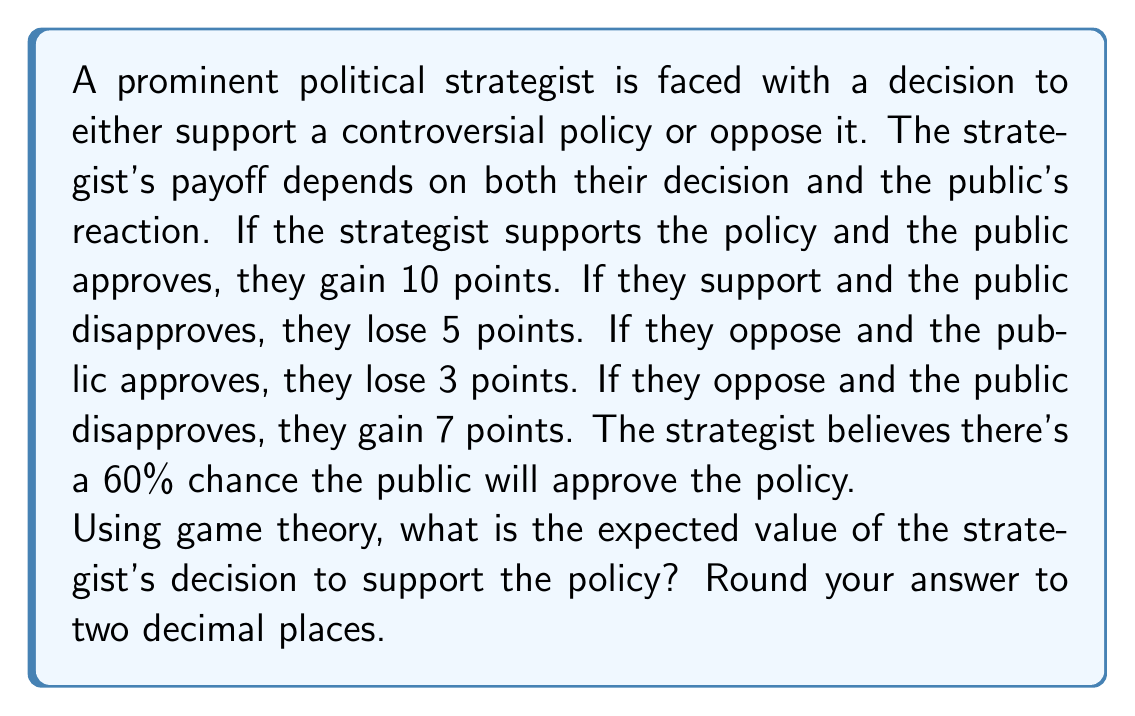Show me your answer to this math problem. To solve this problem, we'll use the concept of expected value from game theory. Let's break it down step-by-step:

1) First, let's define our variables:
   $p$ = probability of public approval = 0.60
   $1-p$ = probability of public disapproval = 0.40

2) Now, let's create a payoff matrix:

   | Strategist's Decision | Public Approves (0.60) | Public Disapproves (0.40) |
   |------------------------|------------------------|---------------------------|
   | Support                | 10                     | -5                        |
   | Oppose                 | -3                     | 7                         |

3) To calculate the expected value of supporting the policy, we multiply each possible outcome by its probability and sum the results:

   $E(\text{Support}) = 10p + (-5)(1-p)$

4) Substituting the value of $p$:

   $E(\text{Support}) = 10(0.60) + (-5)(0.40)$

5) Calculating:

   $E(\text{Support}) = 6 - 2 = 4$

Therefore, the expected value of the strategist's decision to support the policy is 4 points.
Answer: 4.00 